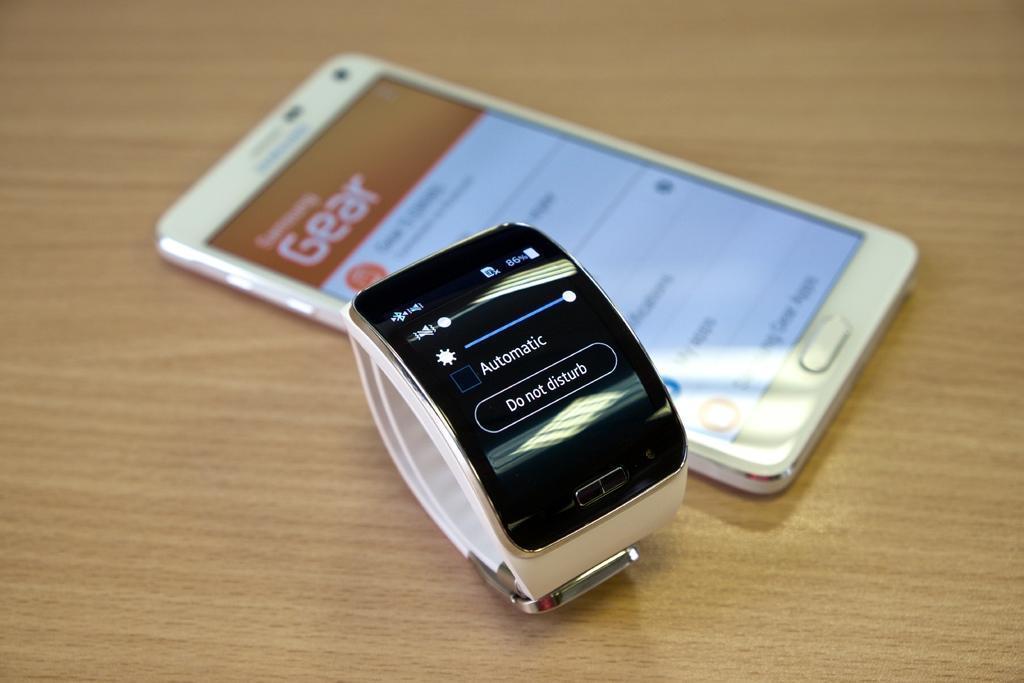In one or two sentences, can you explain what this image depicts? In this image we can see mobile phone and watch which is on the wooden surface. 